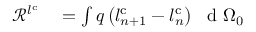<formula> <loc_0><loc_0><loc_500><loc_500>\begin{array} { r l } { \ m a t h s c r { R } ^ { l ^ { c } } } & = \int q \left ( l _ { n + 1 } ^ { c } - l _ { n } ^ { c } \right ) \ d { \Omega _ { 0 } } } \end{array}</formula> 